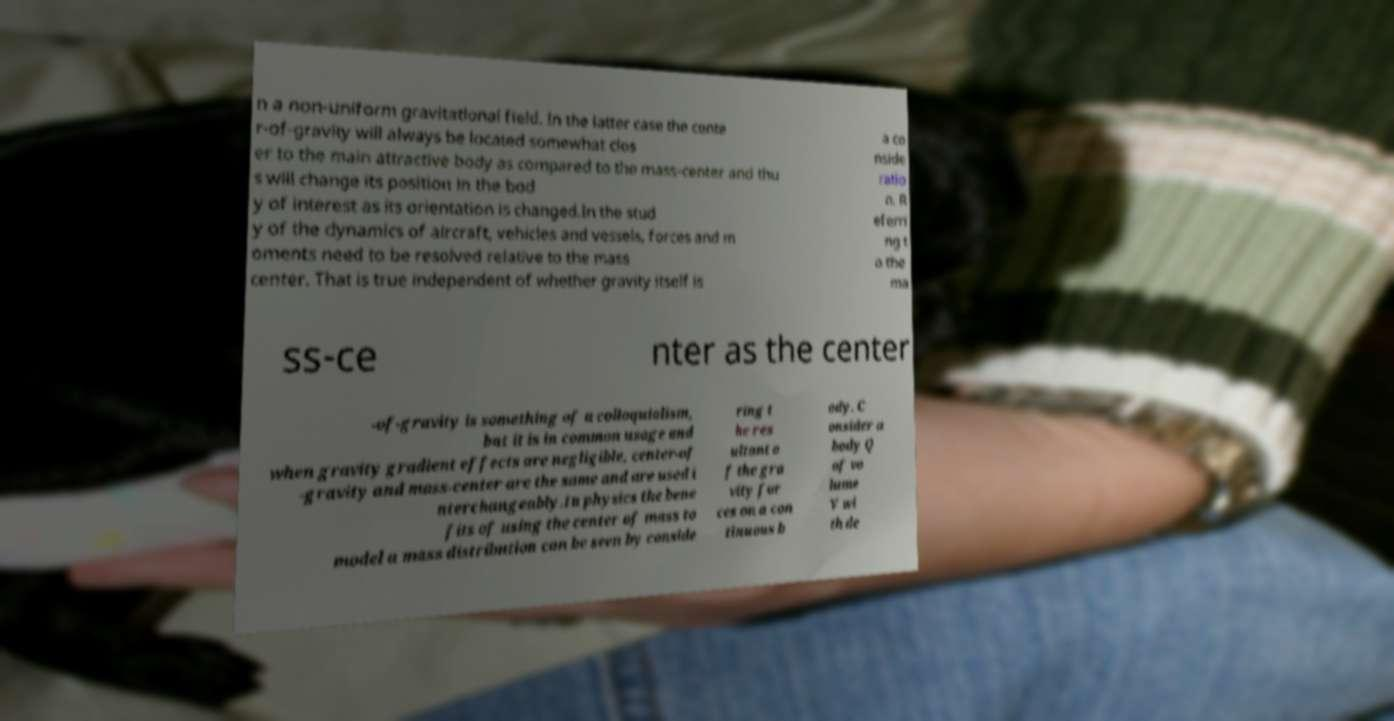Can you read and provide the text displayed in the image?This photo seems to have some interesting text. Can you extract and type it out for me? n a non-uniform gravitational field. In the latter case the cente r-of-gravity will always be located somewhat clos er to the main attractive body as compared to the mass-center and thu s will change its position in the bod y of interest as its orientation is changed.In the stud y of the dynamics of aircraft, vehicles and vessels, forces and m oments need to be resolved relative to the mass center. That is true independent of whether gravity itself is a co nside ratio n. R eferri ng t o the ma ss-ce nter as the center -of-gravity is something of a colloquialism, but it is in common usage and when gravity gradient effects are negligible, center-of -gravity and mass-center are the same and are used i nterchangeably.In physics the bene fits of using the center of mass to model a mass distribution can be seen by conside ring t he res ultant o f the gra vity for ces on a con tinuous b ody. C onsider a body Q of vo lume V wi th de 